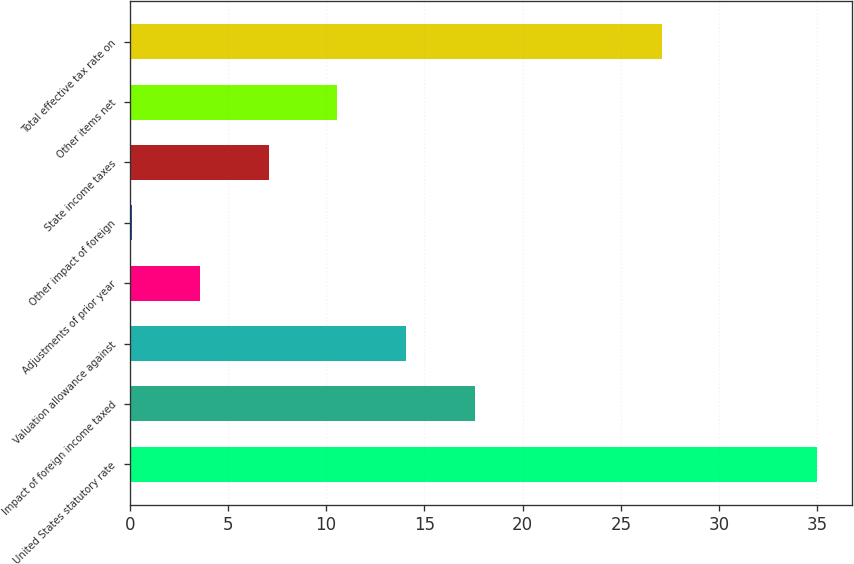Convert chart. <chart><loc_0><loc_0><loc_500><loc_500><bar_chart><fcel>United States statutory rate<fcel>Impact of foreign income taxed<fcel>Valuation allowance against<fcel>Adjustments of prior year<fcel>Other impact of foreign<fcel>State income taxes<fcel>Other items net<fcel>Total effective tax rate on<nl><fcel>35<fcel>17.55<fcel>14.06<fcel>3.59<fcel>0.1<fcel>7.08<fcel>10.57<fcel>27.1<nl></chart> 